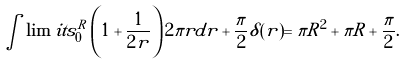Convert formula to latex. <formula><loc_0><loc_0><loc_500><loc_500>\int \lim i t s _ { 0 } ^ { R } \left ( 1 + \frac { 1 } { 2 r } \right ) 2 \pi r d r + \frac { \pi } { 2 } \delta ( r ) = \pi R ^ { 2 } + \pi R + \frac { \pi } { 2 } .</formula> 